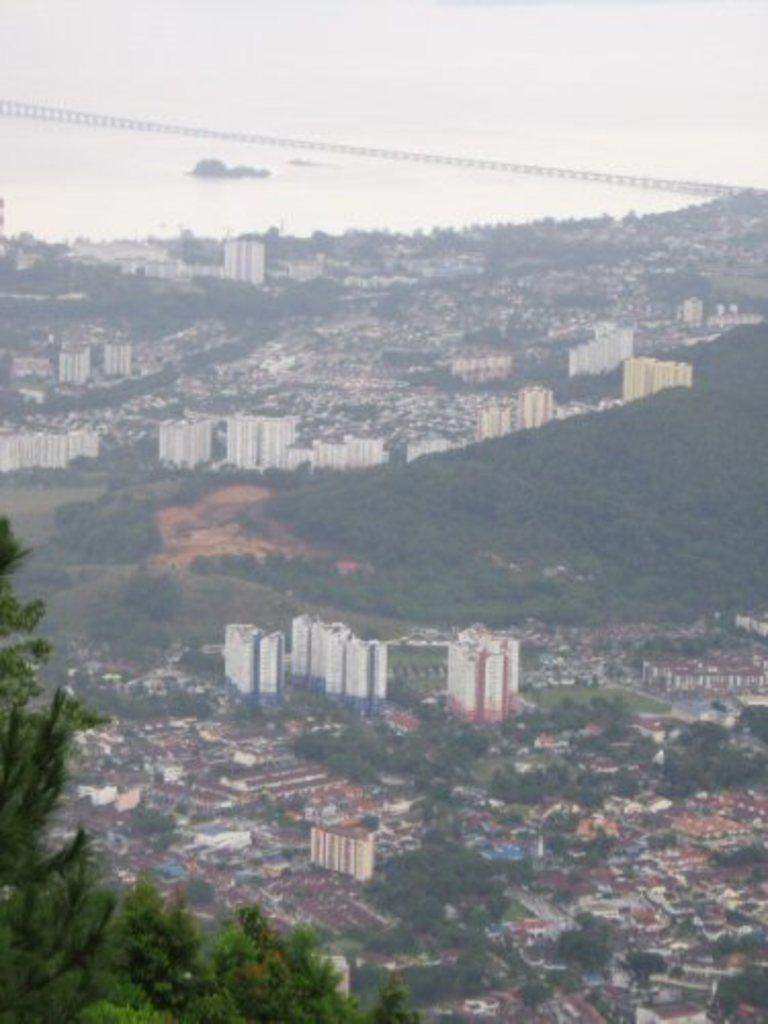What type of view is depicted in the image? The image is an aerial view. What can be seen on the left side of the image? There are trees on the left side of the image. How many buildings are visible in the image? There are many buildings visible in the image. What is present in the background of the image? Trees and water are visible in the background of the image, along with a bridge. What color is the rose in the stomach of the person in the image? There is no rose or person present in the image; it is an aerial view of a landscape with trees, buildings, and a bridge. 